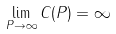<formula> <loc_0><loc_0><loc_500><loc_500>\lim _ { P \rightarrow \infty } C ( P ) = \infty</formula> 